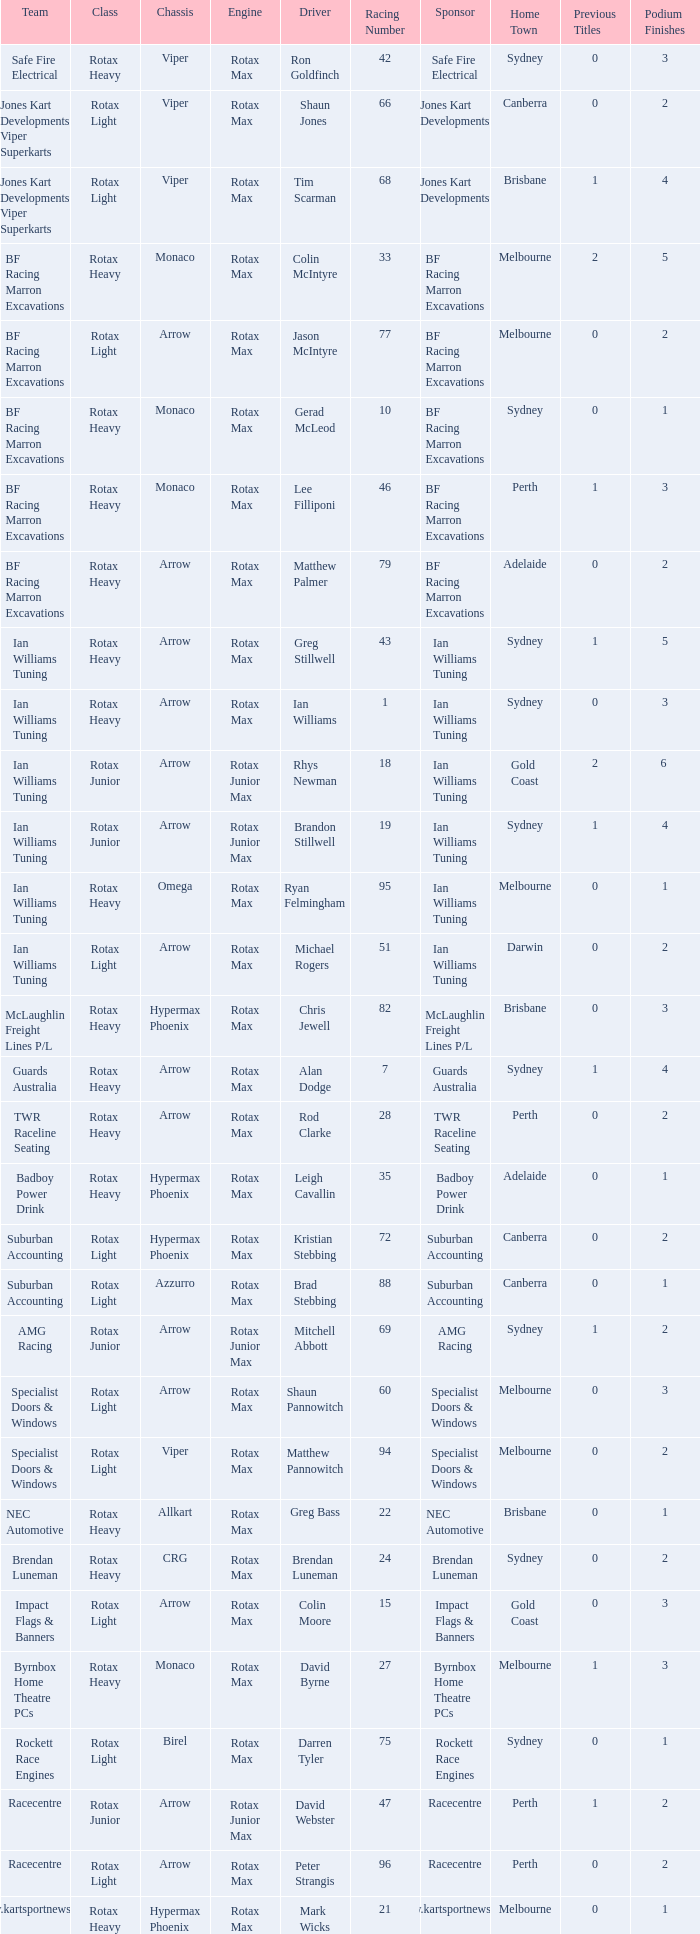What is the name of the driver with a rotax max engine, in the rotax heavy class, with arrow as chassis and on the TWR Raceline Seating team? Rod Clarke. 